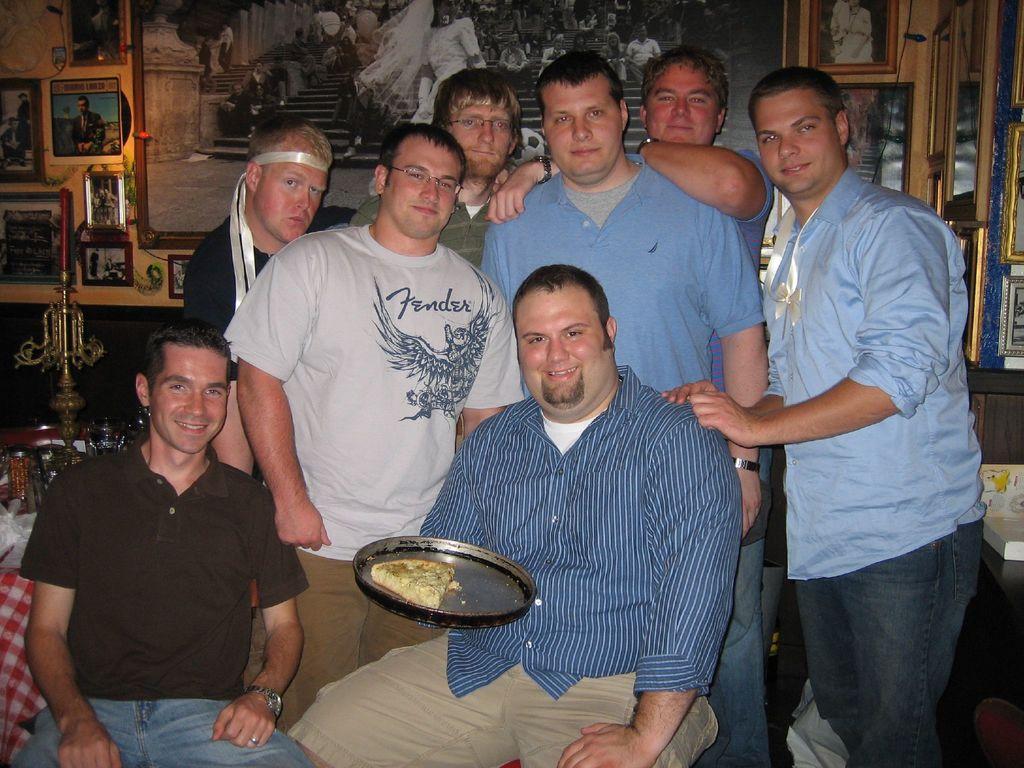How would you summarize this image in a sentence or two? In this image, we can see a group of people are watching. Few people are smiling. At the bottom, we can see two men are sitting and tray with food. Background we can see frames on the wall. On the left side of the image, we can see a stand with candle. 